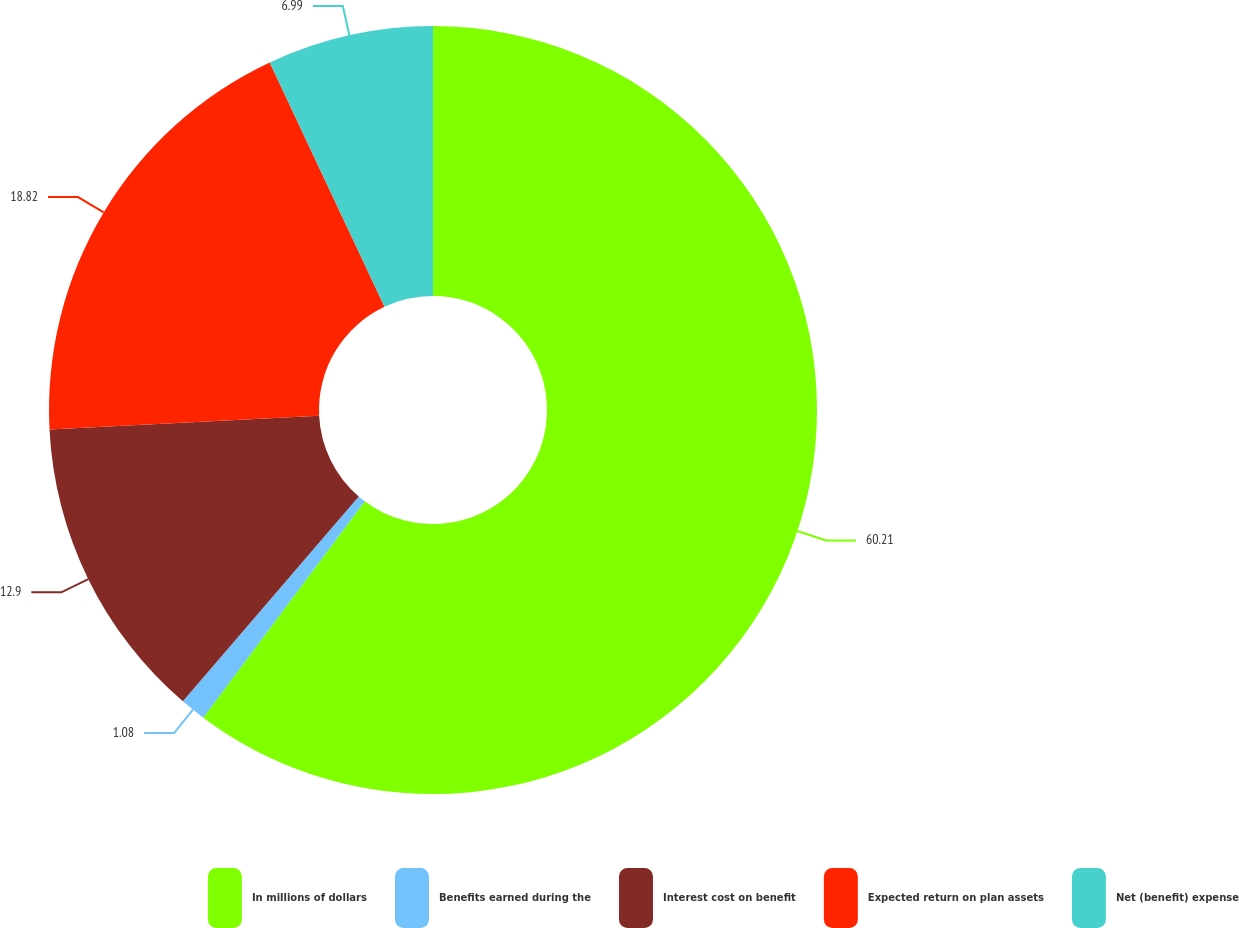Convert chart. <chart><loc_0><loc_0><loc_500><loc_500><pie_chart><fcel>In millions of dollars<fcel>Benefits earned during the<fcel>Interest cost on benefit<fcel>Expected return on plan assets<fcel>Net (benefit) expense<nl><fcel>60.21%<fcel>1.08%<fcel>12.9%<fcel>18.82%<fcel>6.99%<nl></chart> 